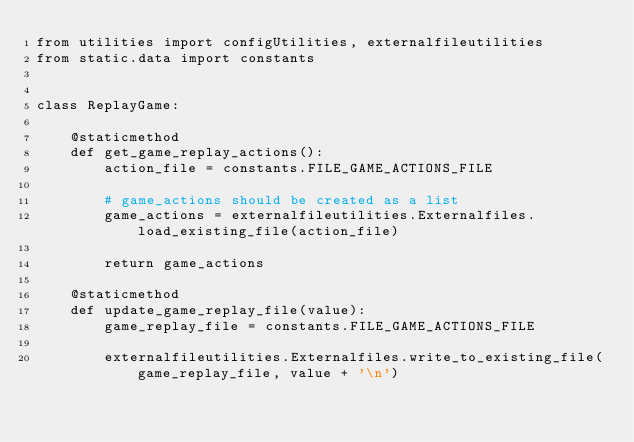<code> <loc_0><loc_0><loc_500><loc_500><_Python_>from utilities import configUtilities, externalfileutilities
from static.data import constants


class ReplayGame:

    @staticmethod
    def get_game_replay_actions():
        action_file = constants.FILE_GAME_ACTIONS_FILE

        # game_actions should be created as a list
        game_actions = externalfileutilities.Externalfiles.load_existing_file(action_file)

        return game_actions

    @staticmethod
    def update_game_replay_file(value):
        game_replay_file = constants.FILE_GAME_ACTIONS_FILE

        externalfileutilities.Externalfiles.write_to_existing_file(game_replay_file, value + '\n')
</code> 